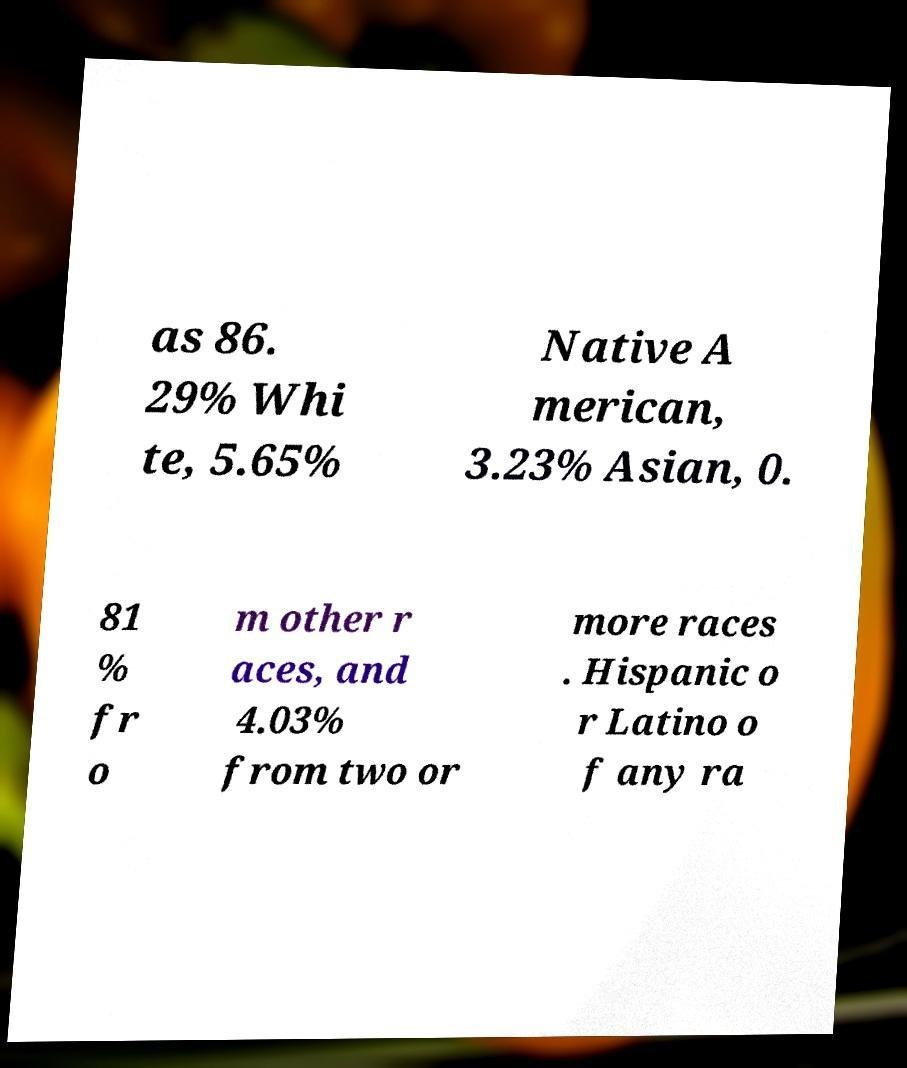Please read and relay the text visible in this image. What does it say? as 86. 29% Whi te, 5.65% Native A merican, 3.23% Asian, 0. 81 % fr o m other r aces, and 4.03% from two or more races . Hispanic o r Latino o f any ra 